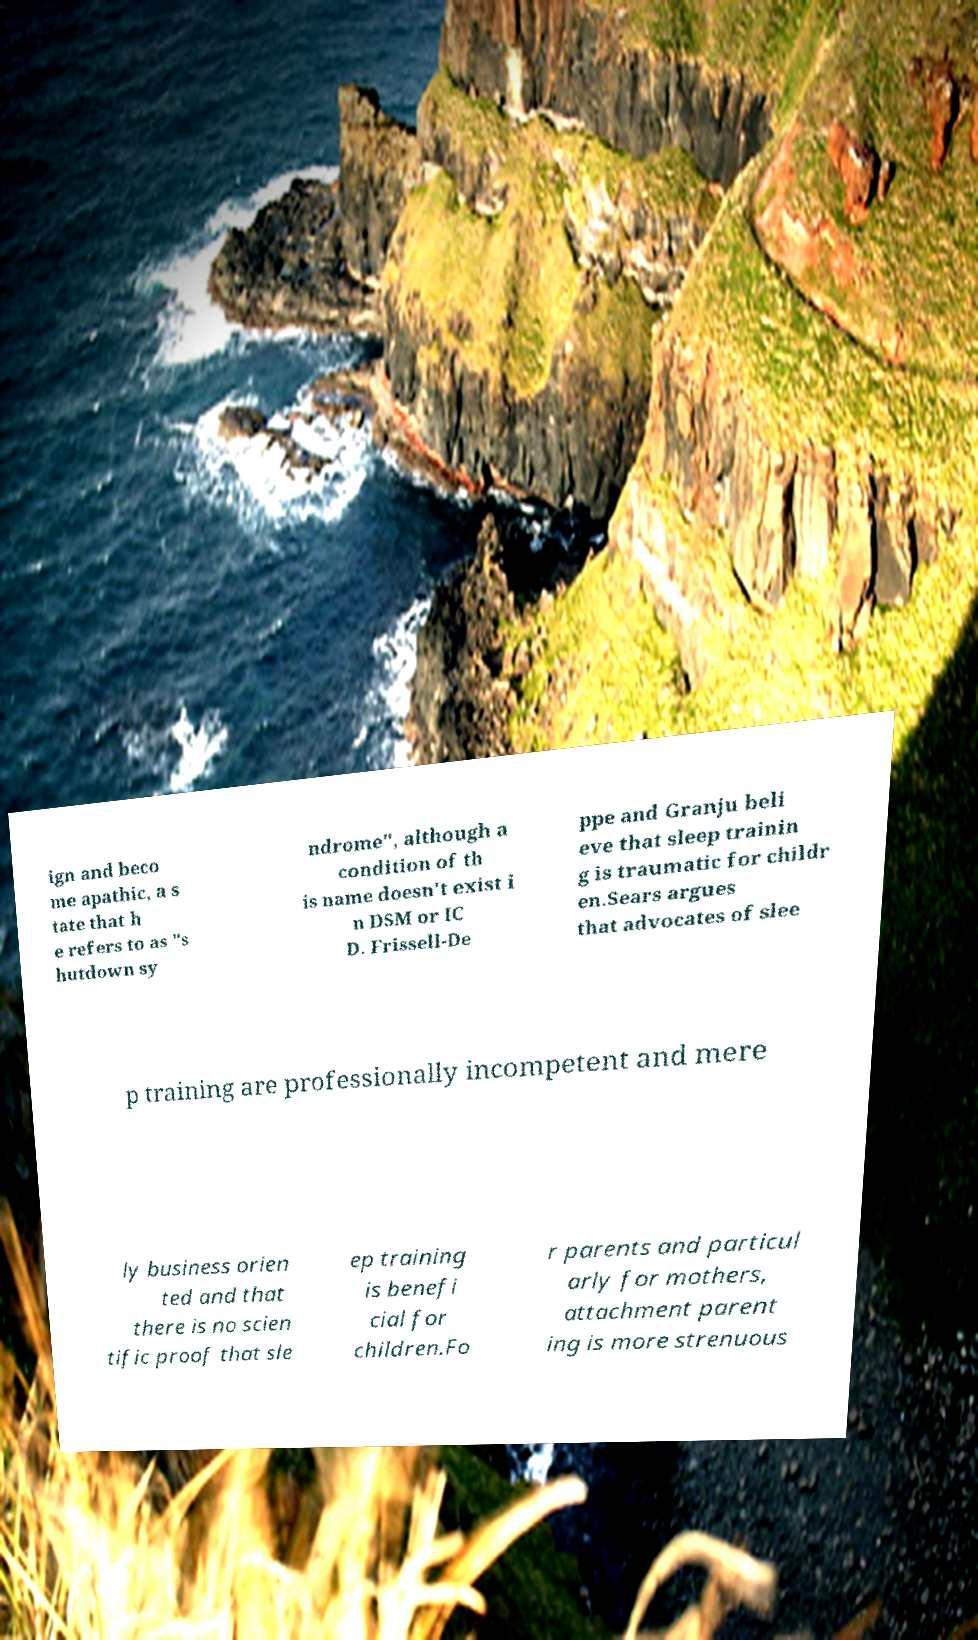Please read and relay the text visible in this image. What does it say? ign and beco me apathic, a s tate that h e refers to as "s hutdown sy ndrome", although a condition of th is name doesn't exist i n DSM or IC D. Frissell-De ppe and Granju beli eve that sleep trainin g is traumatic for childr en.Sears argues that advocates of slee p training are professionally incompetent and mere ly business orien ted and that there is no scien tific proof that sle ep training is benefi cial for children.Fo r parents and particul arly for mothers, attachment parent ing is more strenuous 